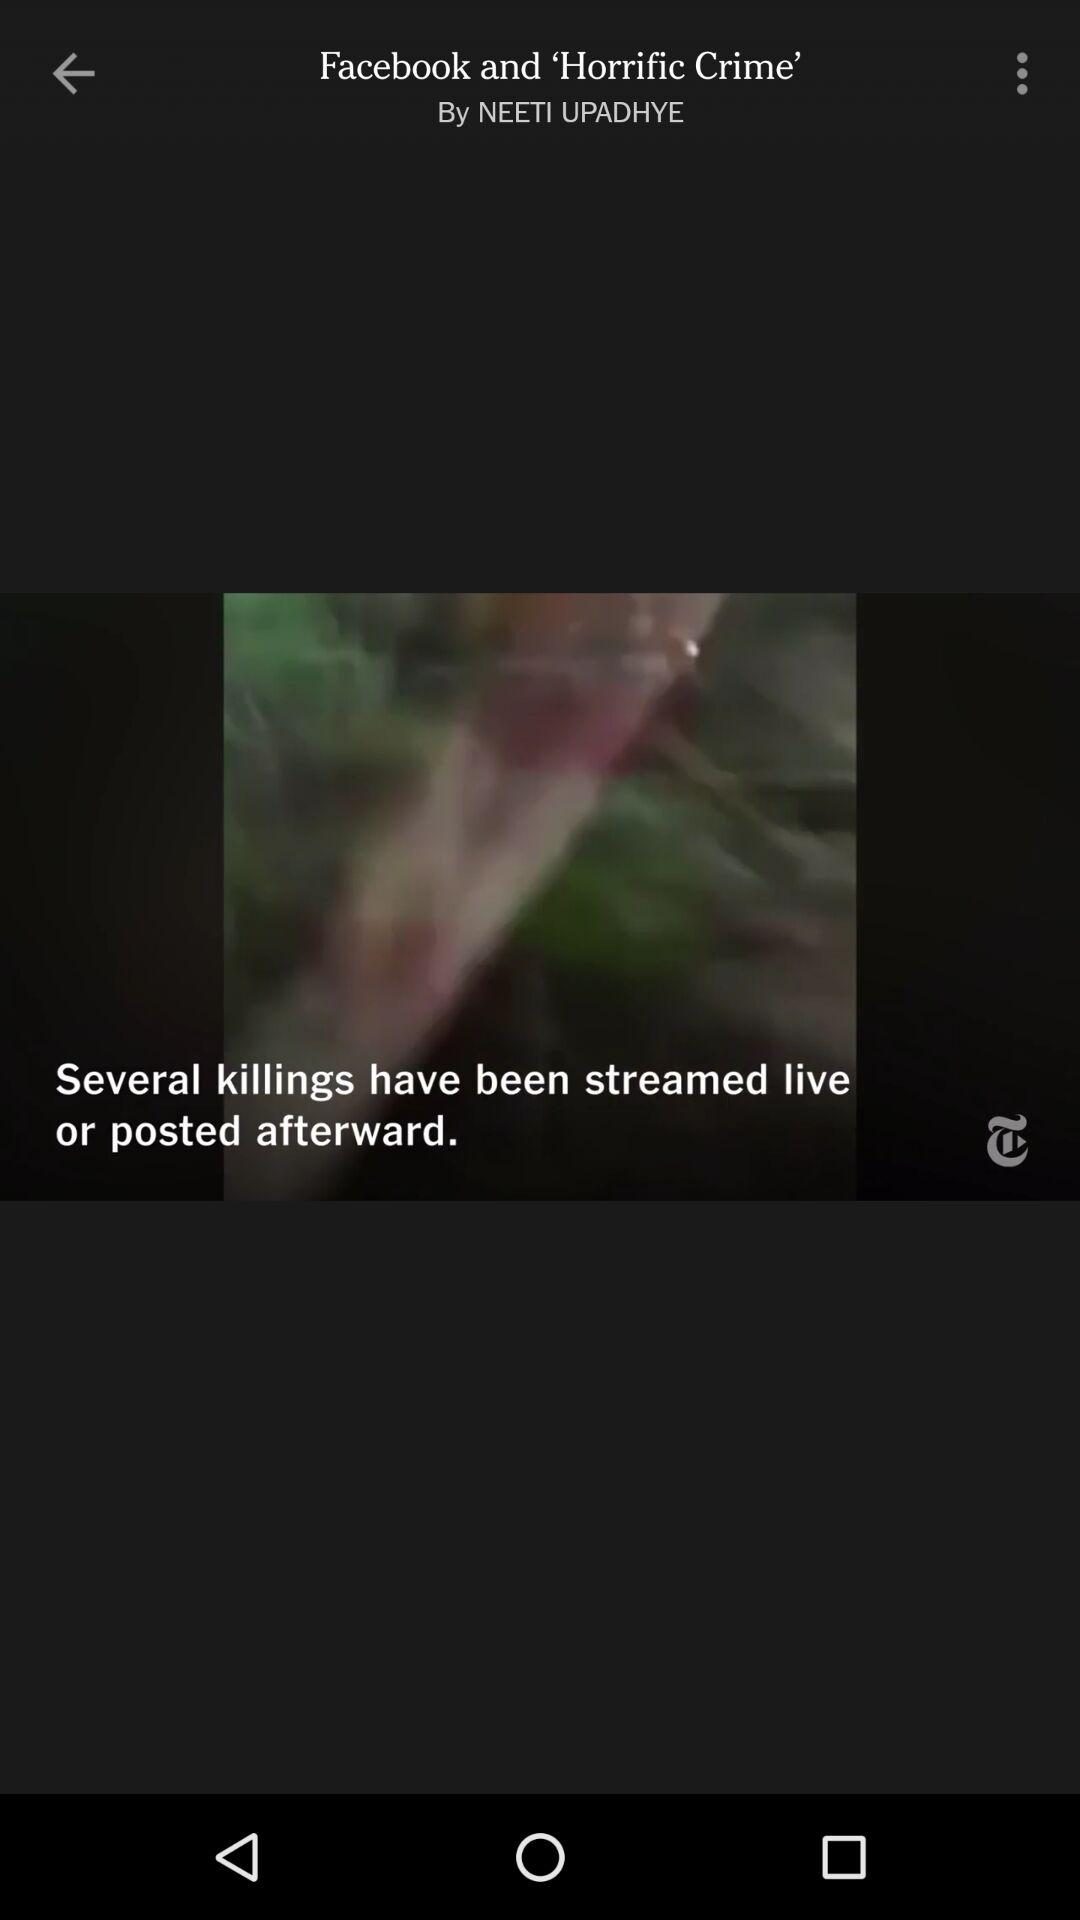What is the name of the video?
When the provided information is insufficient, respond with <no answer>. <no answer> 